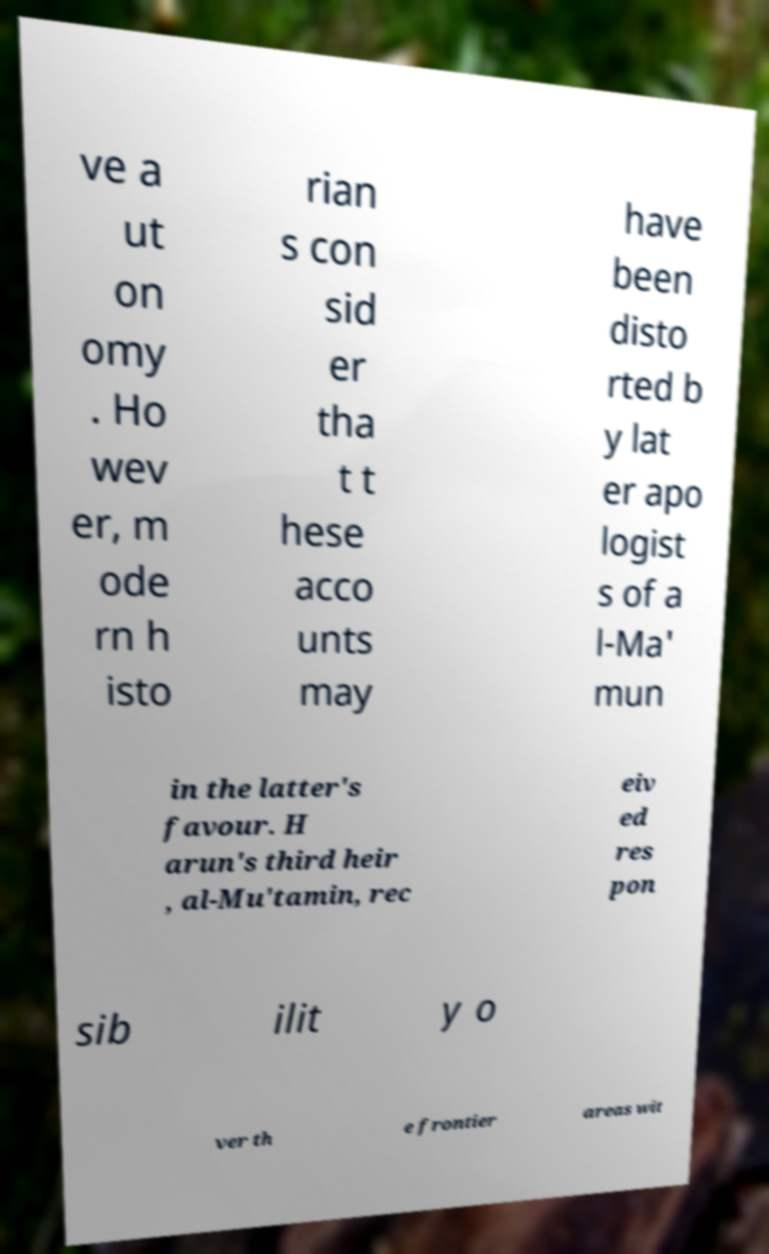For documentation purposes, I need the text within this image transcribed. Could you provide that? ve a ut on omy . Ho wev er, m ode rn h isto rian s con sid er tha t t hese acco unts may have been disto rted b y lat er apo logist s of a l-Ma' mun in the latter's favour. H arun's third heir , al-Mu'tamin, rec eiv ed res pon sib ilit y o ver th e frontier areas wit 